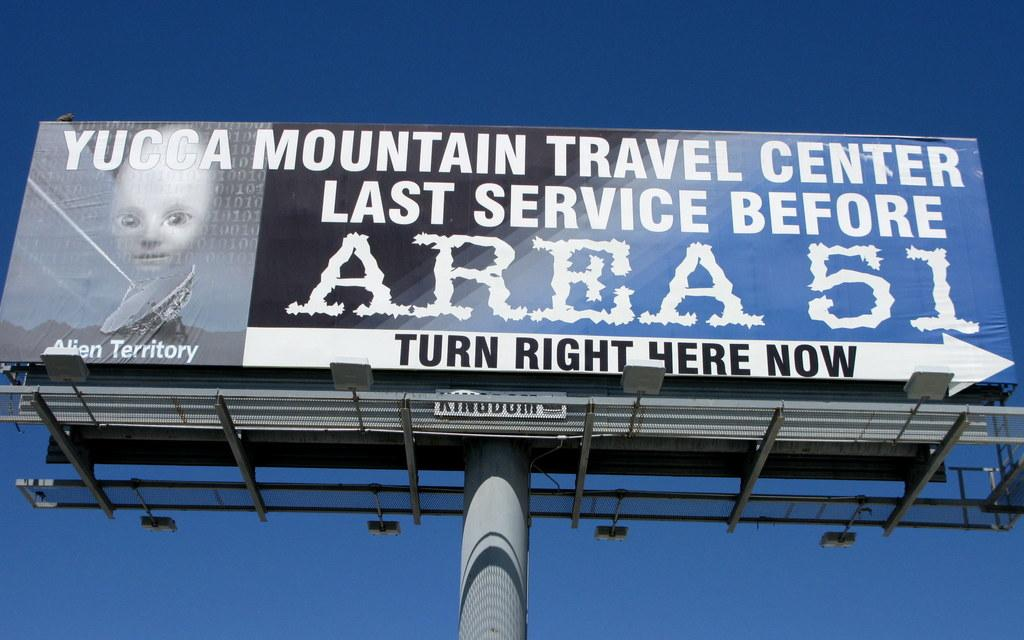<image>
Write a terse but informative summary of the picture. a large billboard with Area 51 written on it 